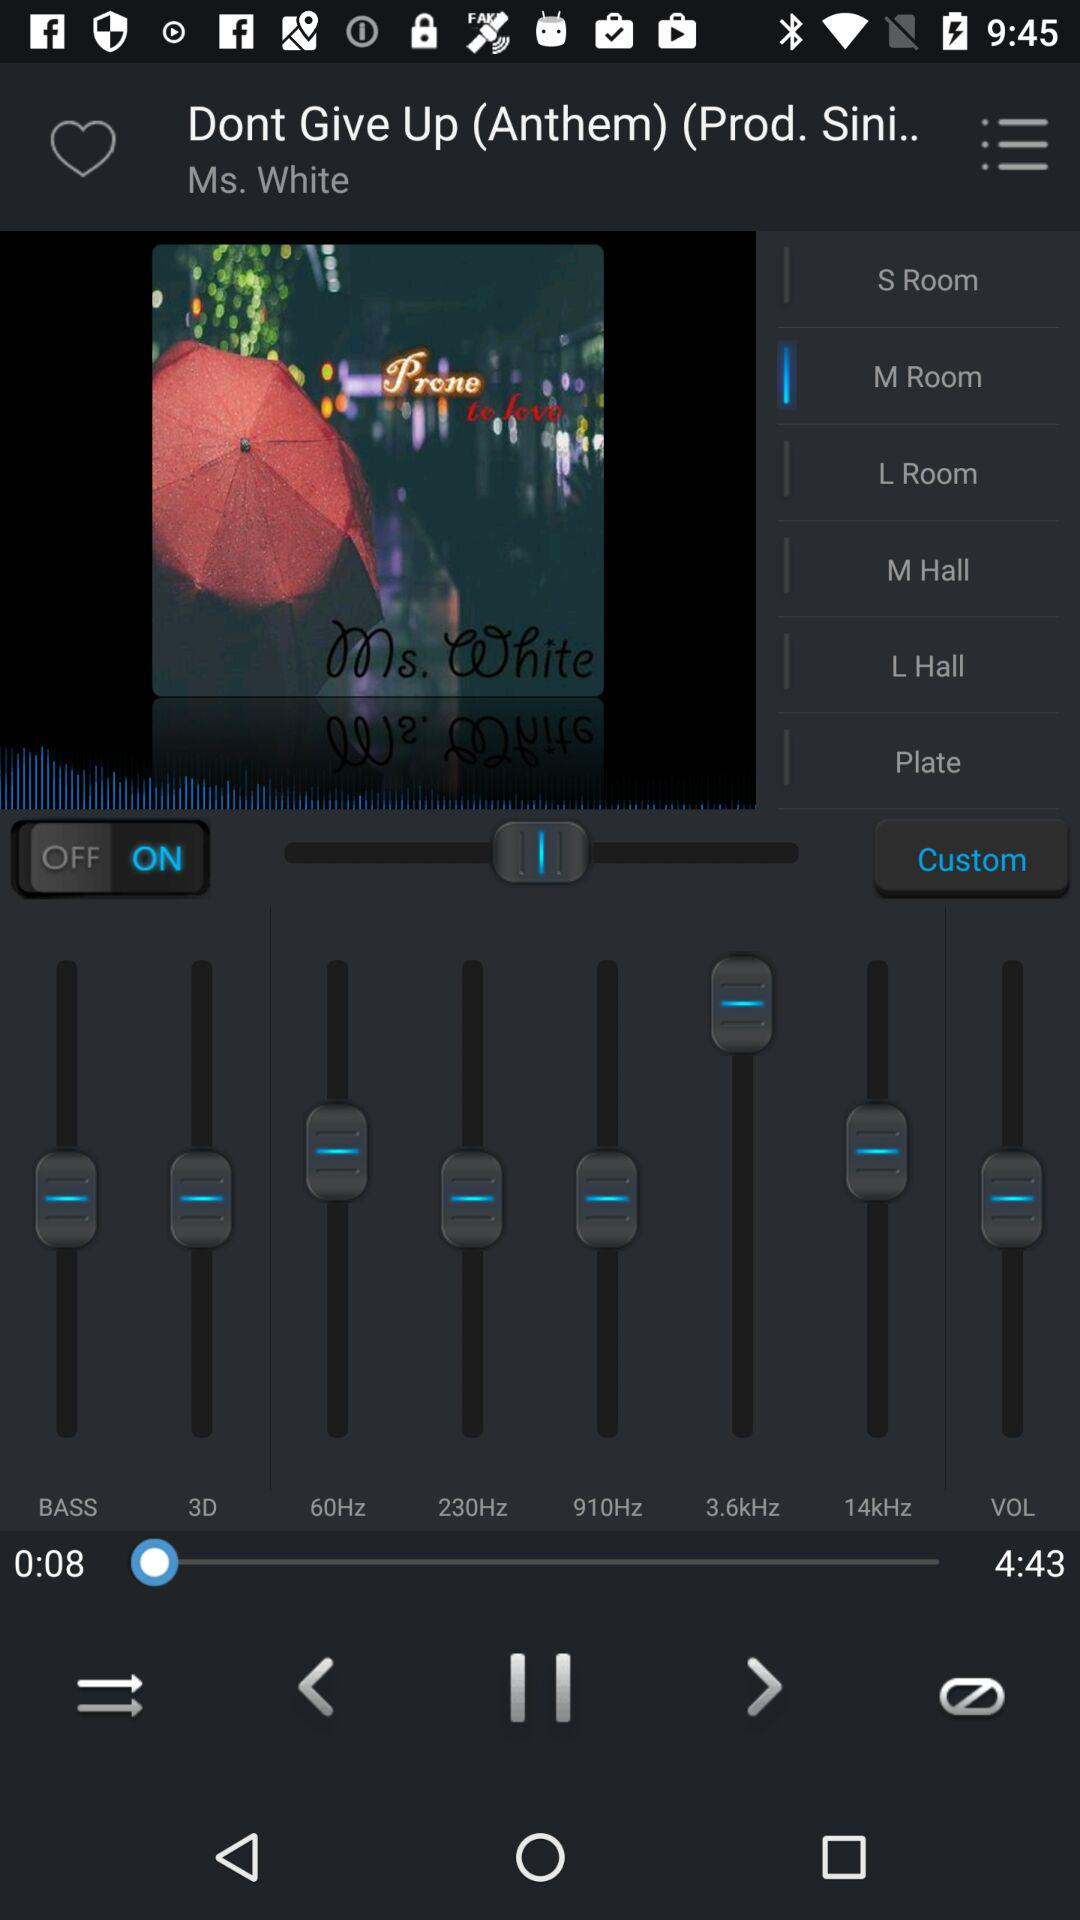Who is the singer? The singer is Ms. White. 